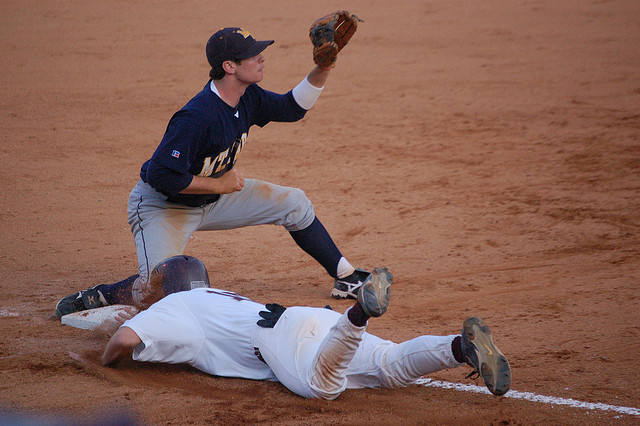Identify the text contained in this image. MT 